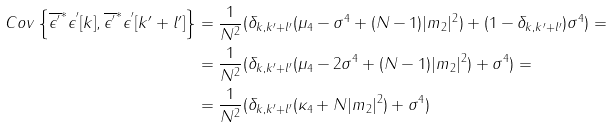<formula> <loc_0><loc_0><loc_500><loc_500>C o v \left \{ \overline { \epsilon ^ { ^ { \prime } } } ^ { * } \epsilon ^ { ^ { \prime } } [ k ] , \overline { \epsilon ^ { ^ { \prime } } } ^ { * } \epsilon ^ { ^ { \prime } } [ k ^ { \prime } + l ^ { \prime } ] \right \} & = \frac { 1 } { N ^ { 2 } } ( \delta _ { k , k ^ { \prime } + l ^ { \prime } } ( \mu _ { 4 } - \sigma ^ { 4 } + ( N - 1 ) | m _ { 2 } | ^ { 2 } ) + ( 1 - \delta _ { k , k ^ { \prime } + l ^ { \prime } } ) \sigma ^ { 4 } ) = \\ & = \frac { 1 } { N ^ { 2 } } ( \delta _ { k , k ^ { \prime } + l ^ { \prime } } ( \mu _ { 4 } - 2 \sigma ^ { 4 } + ( N - 1 ) | m _ { 2 } | ^ { 2 } ) + \sigma ^ { 4 } ) = \\ & = \frac { 1 } { N ^ { 2 } } ( \delta _ { k , k ^ { \prime } + l ^ { \prime } } ( \kappa _ { 4 } + N | m _ { 2 } | ^ { 2 } ) + \sigma ^ { 4 } )</formula> 